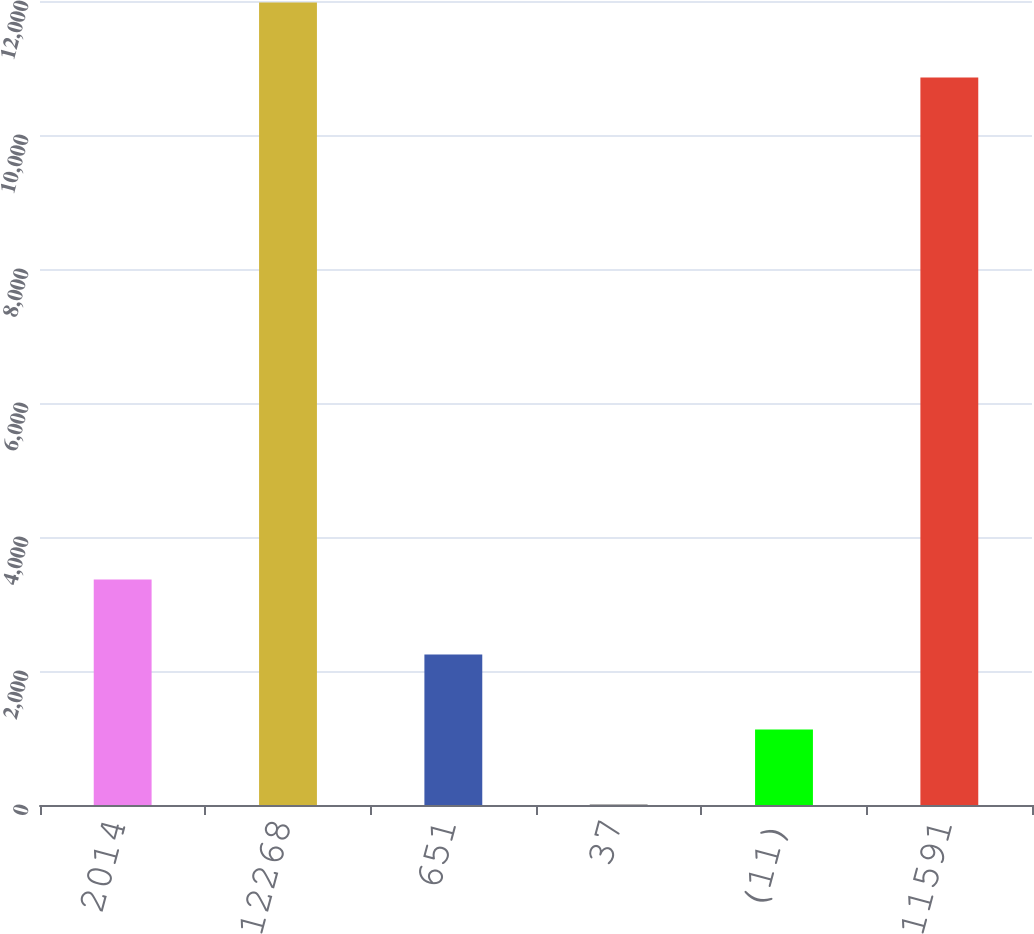Convert chart. <chart><loc_0><loc_0><loc_500><loc_500><bar_chart><fcel>2014<fcel>12268<fcel>651<fcel>37<fcel>(11)<fcel>11591<nl><fcel>3364.6<fcel>11976.2<fcel>2245.4<fcel>7<fcel>1126.2<fcel>10857<nl></chart> 